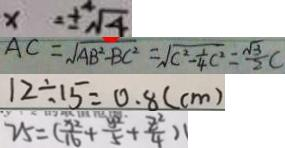<formula> <loc_0><loc_0><loc_500><loc_500>x = \pm \sqrt [ 4 ] { 4 } 
 A C = \sqrt { A B ^ { 2 } - B C ^ { 2 } } = \sqrt { c ^ { 2 } - \frac { 1 } { 4 } c ^ { 2 } } = \frac { \sqrt { 3 } } { 2 } C 
 1 2 \div 1 5 = 0 . 8 ( c m ) 
 2 5 = ( \frac { x ^ { 2 } } { 1 6 } + \frac { y ^ { 2 } } { 5 } + \frac { z ^ { 2 } } { 4 } )</formula> 